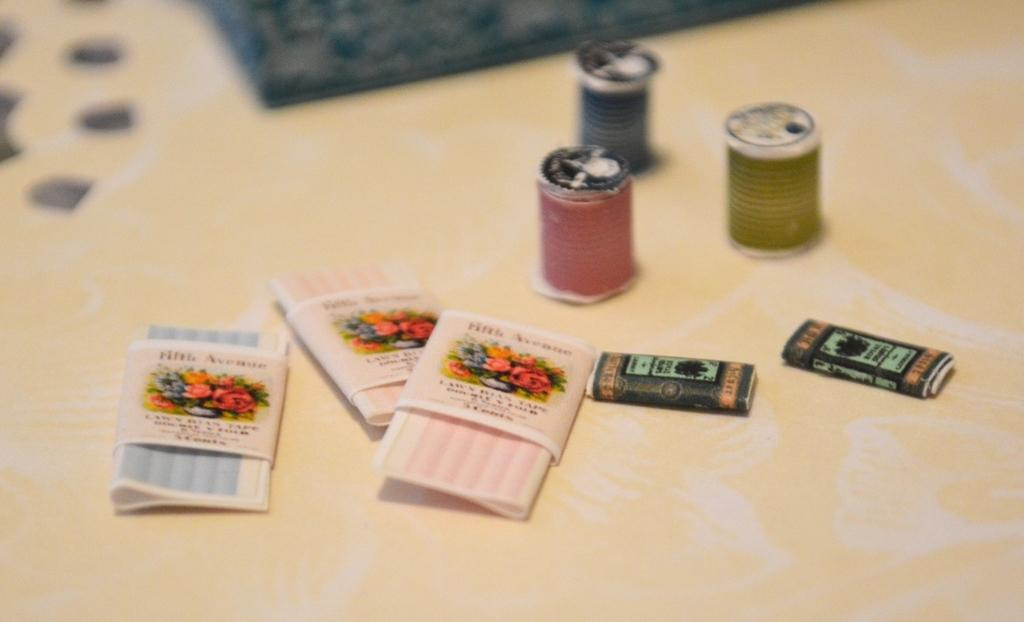What is the color of the surface on which the objects are placed in the image? The surface is cream-colored. What colors can be seen among the objects in the image? The objects have colors including red, green, black, and pink. What time does the clock show in the image? There is no clock present in the image, so it is not possible to determine the time. 